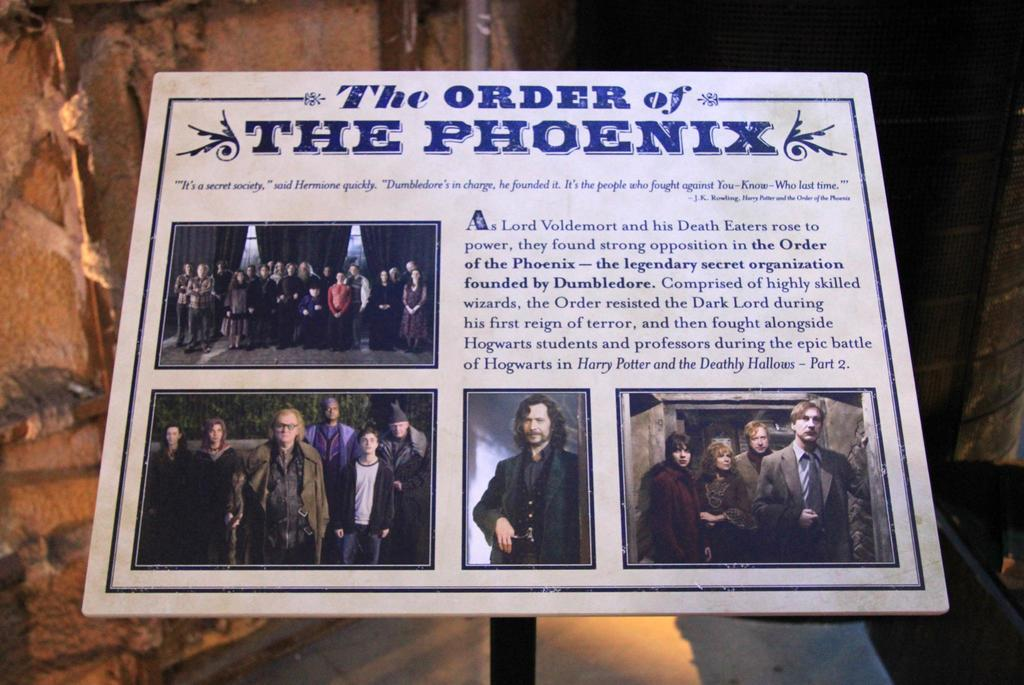<image>
Provide a brief description of the given image. A white information sign with pictures on a black post about The order of the Phoenix. 